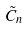<formula> <loc_0><loc_0><loc_500><loc_500>\tilde { C } _ { n }</formula> 